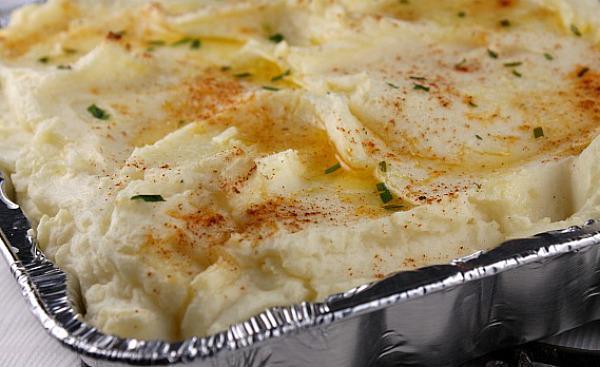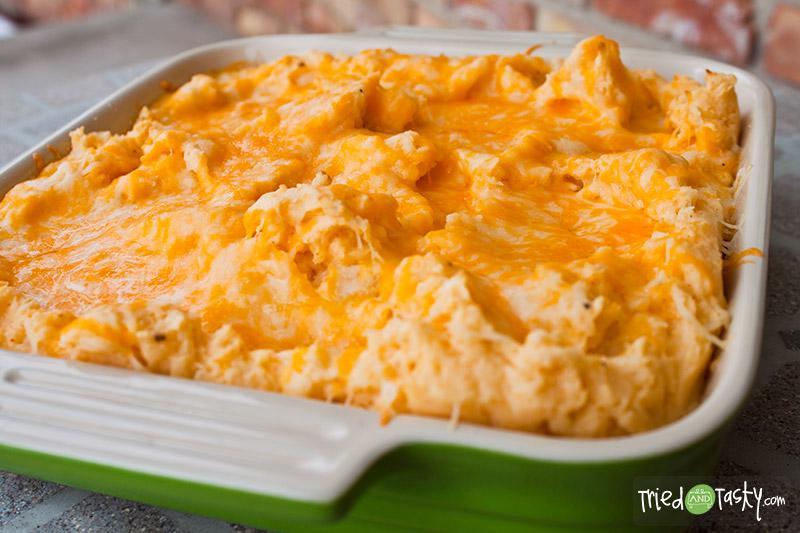The first image is the image on the left, the second image is the image on the right. Assess this claim about the two images: "There are sppons near mashed potatoes.". Correct or not? Answer yes or no. No. 